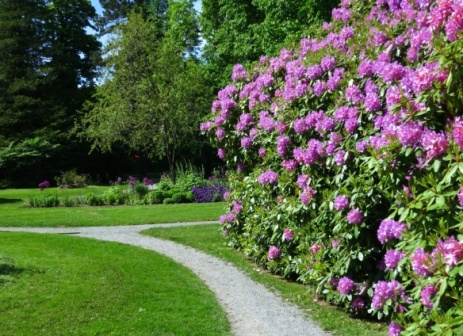Analyze the image in a comprehensive and detailed manner. The image presents a meticulously maintained garden path that winds elegantly through a lush landscape. This path, composed of finely laid white stones, contrasts vividly against the rich green hues of the lawn and shrubbery. To the right, a vibrant bush bursts with pink flowers, likely emitting a gentle fragrance that enriches the garden's air. The garden beckons viewers to explore further into its depths, surrounded by assorted greenery that includes both tall trees and shorter bushes, suggesting a well-planned diversity in vegetation. This setting could possibly be a part of a larger park, meant for leisurely walks or reflective solitude. The absence of any visible human activity or modern elements adds a timeless quality to the scene, encouraging the viewer to imagine the soft rustle of leaves and the chirping of birds that might accompany such a serene setting. 